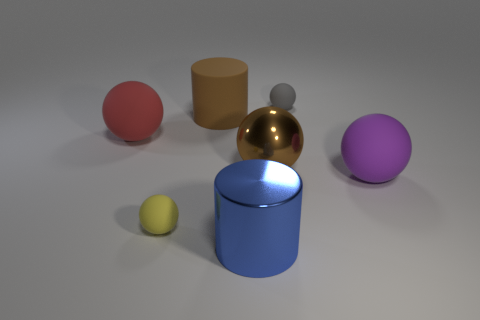Subtract all gray balls. How many balls are left? 4 Subtract all purple balls. How many balls are left? 4 Subtract 0 yellow cubes. How many objects are left? 7 Subtract all balls. How many objects are left? 2 Subtract 2 balls. How many balls are left? 3 Subtract all red balls. Subtract all green blocks. How many balls are left? 4 Subtract all yellow balls. How many blue cylinders are left? 1 Subtract all large brown things. Subtract all small gray things. How many objects are left? 4 Add 2 tiny gray matte balls. How many tiny gray matte balls are left? 3 Add 4 tiny matte balls. How many tiny matte balls exist? 6 